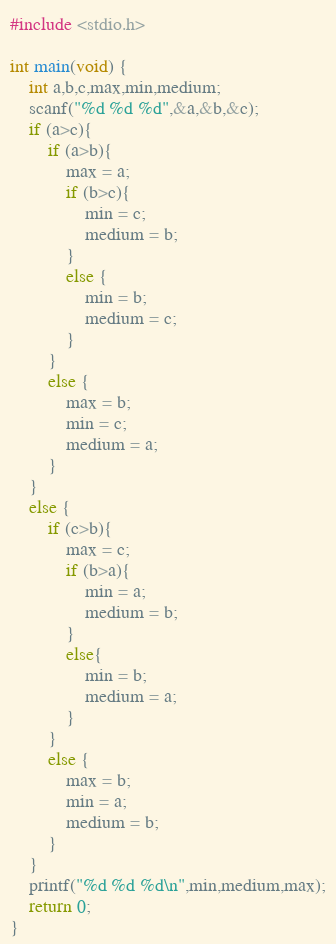Convert code to text. <code><loc_0><loc_0><loc_500><loc_500><_C_>#include <stdio.h>

int main(void) {
    int a,b,c,max,min,medium;
    scanf("%d %d %d",&a,&b,&c);
    if (a>c){
        if (a>b){
            max = a;
            if (b>c){
                min = c;
                medium = b;
            }
            else {
                min = b;
                medium = c;
            }
        }
        else {
            max = b;
            min = c;
            medium = a;
        }
    }
    else {
        if (c>b){
            max = c;
            if (b>a){
                min = a;
                medium = b;
            }
            else{
                min = b;
                medium = a;
            }
        }
        else {
            max = b;
            min = a;
            medium = b;
        }
    }
    printf("%d %d %d\n",min,medium,max);
    return 0;
}</code> 